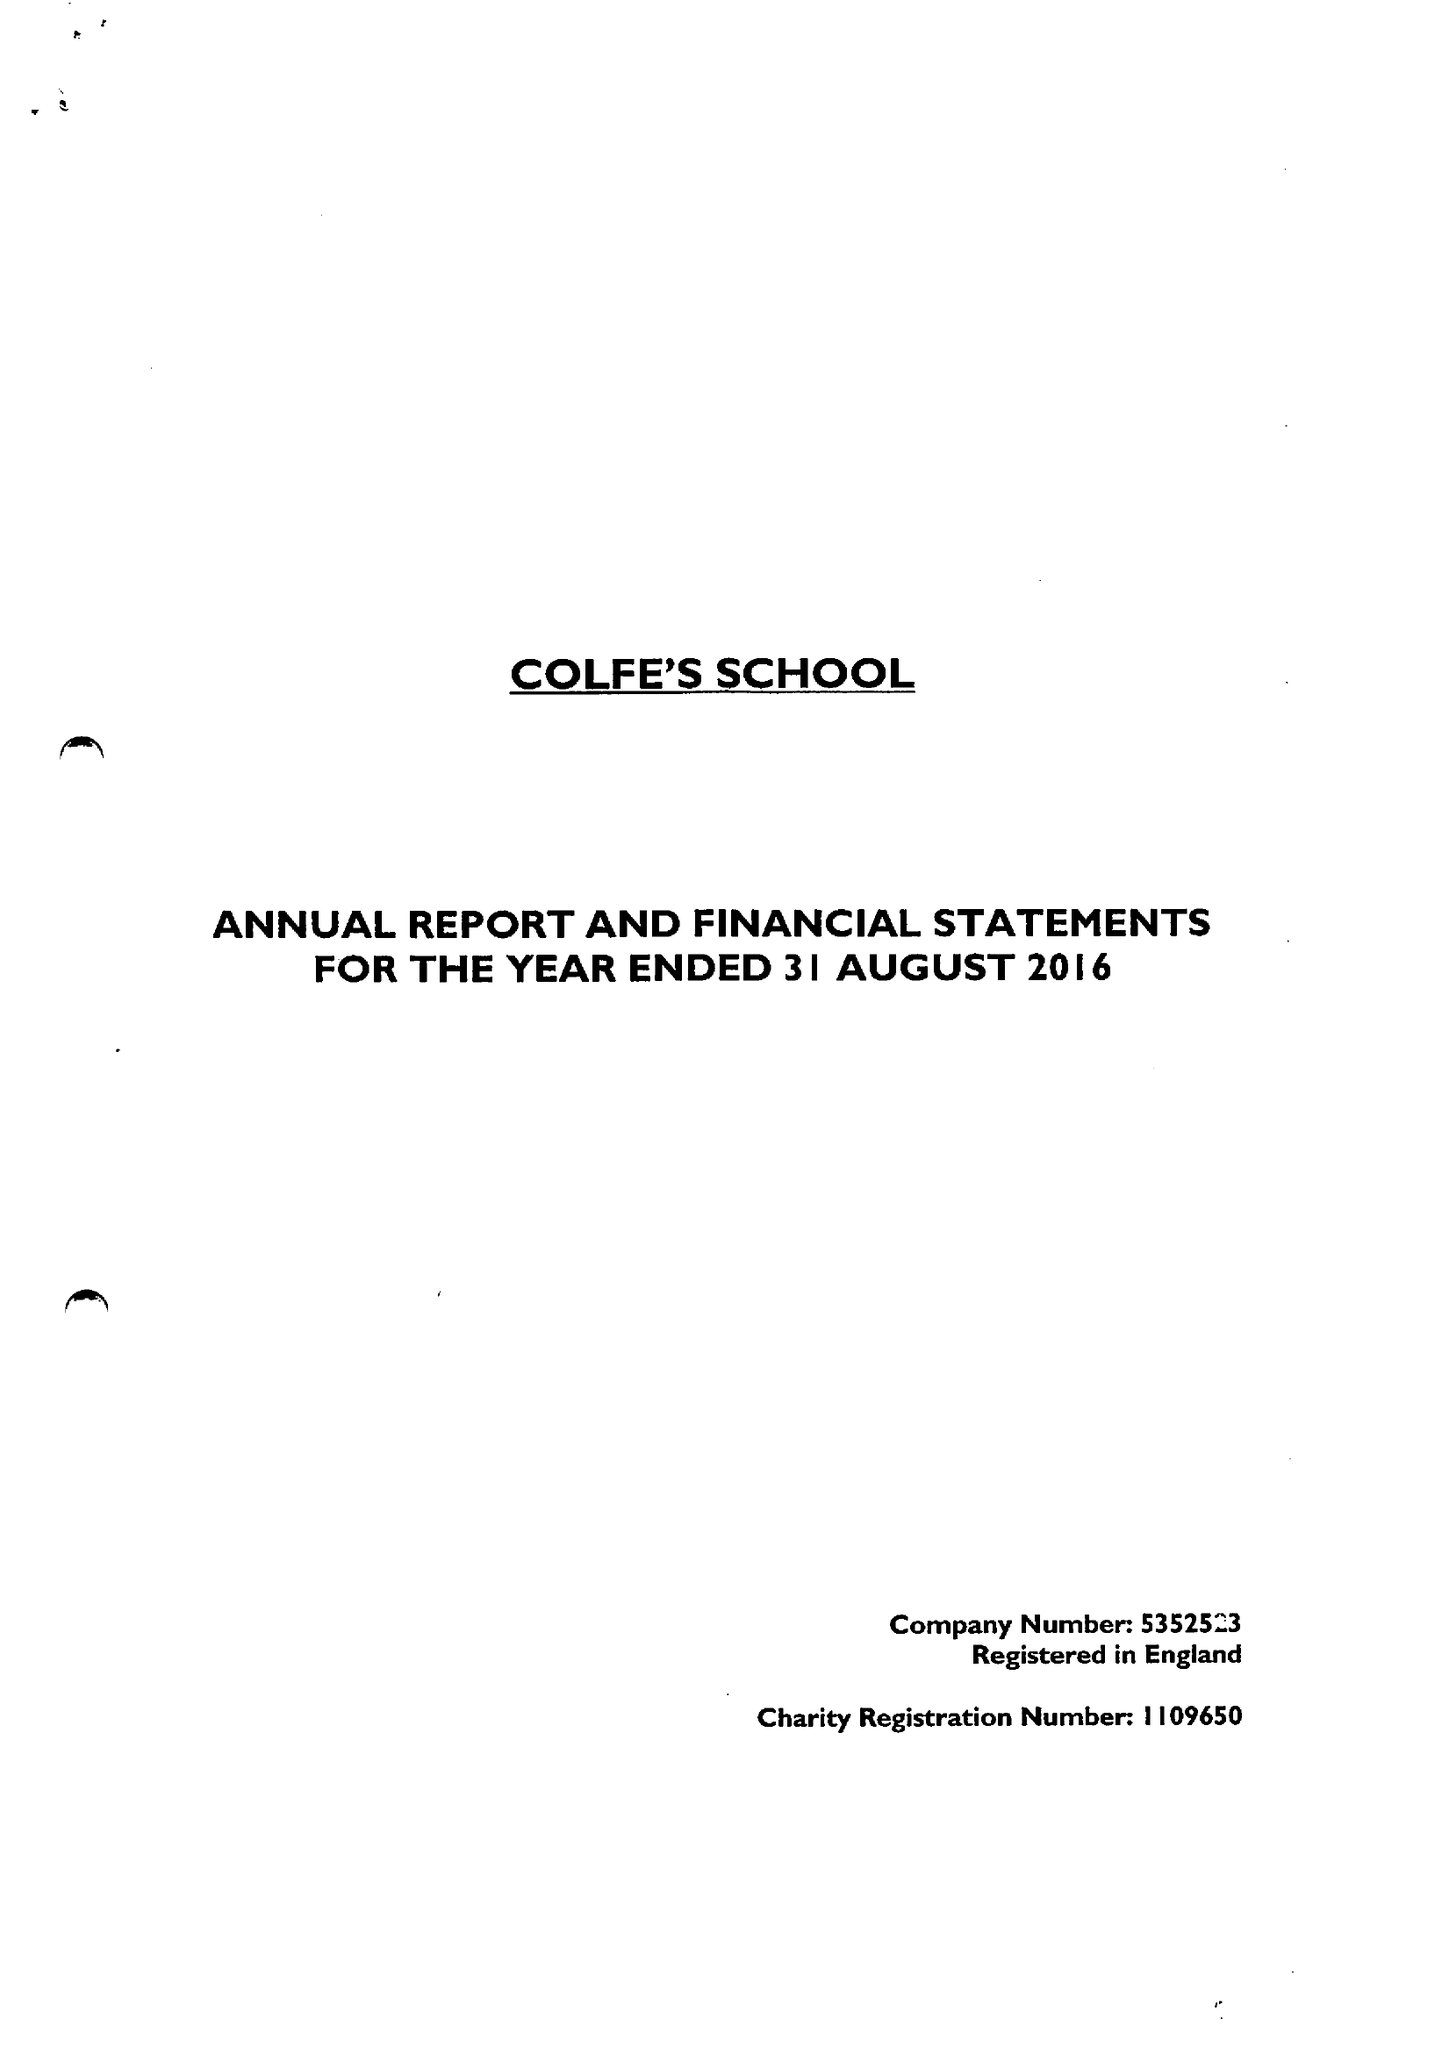What is the value for the income_annually_in_british_pounds?
Answer the question using a single word or phrase. 15430000.00 